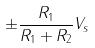Convert formula to latex. <formula><loc_0><loc_0><loc_500><loc_500>\pm \frac { R _ { 1 } } { R _ { 1 } + R _ { 2 } } V _ { s }</formula> 